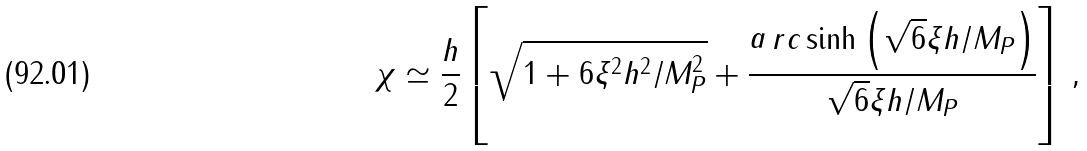Convert formula to latex. <formula><loc_0><loc_0><loc_500><loc_500>\chi \simeq \frac { h } { 2 } \left [ \sqrt { 1 + 6 \xi ^ { 2 } h ^ { 2 } / M _ { P } ^ { 2 } } + \frac { \mathop a r c \sinh \left ( \sqrt { 6 } \xi h / M _ { P } \right ) } { \sqrt { 6 } \xi h / M _ { P } } \right ] \, ,</formula> 